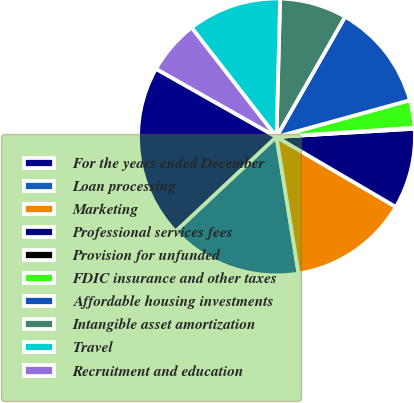Convert chart to OTSL. <chart><loc_0><loc_0><loc_500><loc_500><pie_chart><fcel>For the years ended December<fcel>Loan processing<fcel>Marketing<fcel>Professional services fees<fcel>Provision for unfunded<fcel>FDIC insurance and other taxes<fcel>Affordable housing investments<fcel>Intangible asset amortization<fcel>Travel<fcel>Recruitment and education<nl><fcel>20.18%<fcel>15.56%<fcel>14.01%<fcel>9.38%<fcel>0.12%<fcel>3.21%<fcel>12.47%<fcel>7.84%<fcel>10.93%<fcel>6.3%<nl></chart> 